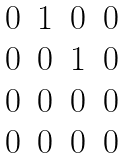Convert formula to latex. <formula><loc_0><loc_0><loc_500><loc_500>\begin{matrix} 0 & 1 & 0 & 0 \\ 0 & 0 & 1 & 0 \\ 0 & 0 & 0 & 0 \\ 0 & 0 & 0 & 0 \end{matrix}</formula> 